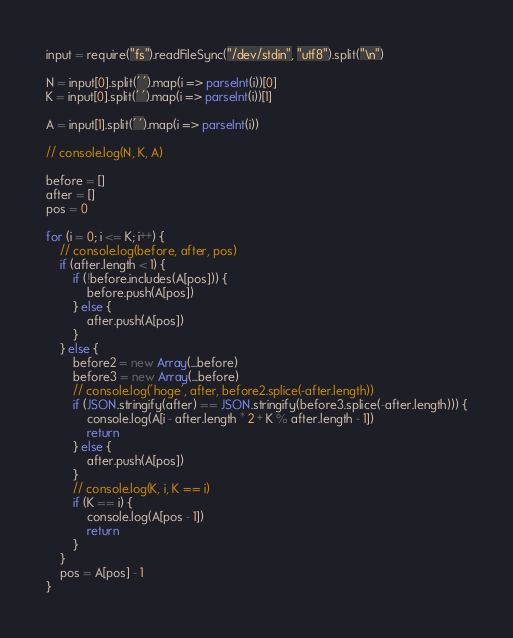Convert code to text. <code><loc_0><loc_0><loc_500><loc_500><_JavaScript_>input = require("fs").readFileSync("/dev/stdin", "utf8").split("\n")

N = input[0].split(' ').map(i => parseInt(i))[0]
K = input[0].split(' ').map(i => parseInt(i))[1]

A = input[1].split(' ').map(i => parseInt(i))

// console.log(N, K, A)

before = []
after = []
pos = 0

for (i = 0; i <= K; i++) {
    // console.log(before, after, pos)
    if (after.length < 1) {
        if (!before.includes(A[pos])) {
            before.push(A[pos])
        } else {
            after.push(A[pos])
        }
    } else {
        before2 = new Array(...before)
        before3 = new Array(...before)
        // console.log('hoge', after, before2.splice(-after.length))
        if (JSON.stringify(after) == JSON.stringify(before3.splice(-after.length))) {
            console.log(A[i - after.length * 2 + K % after.length - 1])
            return
        } else {
            after.push(A[pos])
        }
        // console.log(K, i, K == i)
        if (K == i) {
            console.log(A[pos - 1])
            return
        }
    }
    pos = A[pos] - 1
}
</code> 